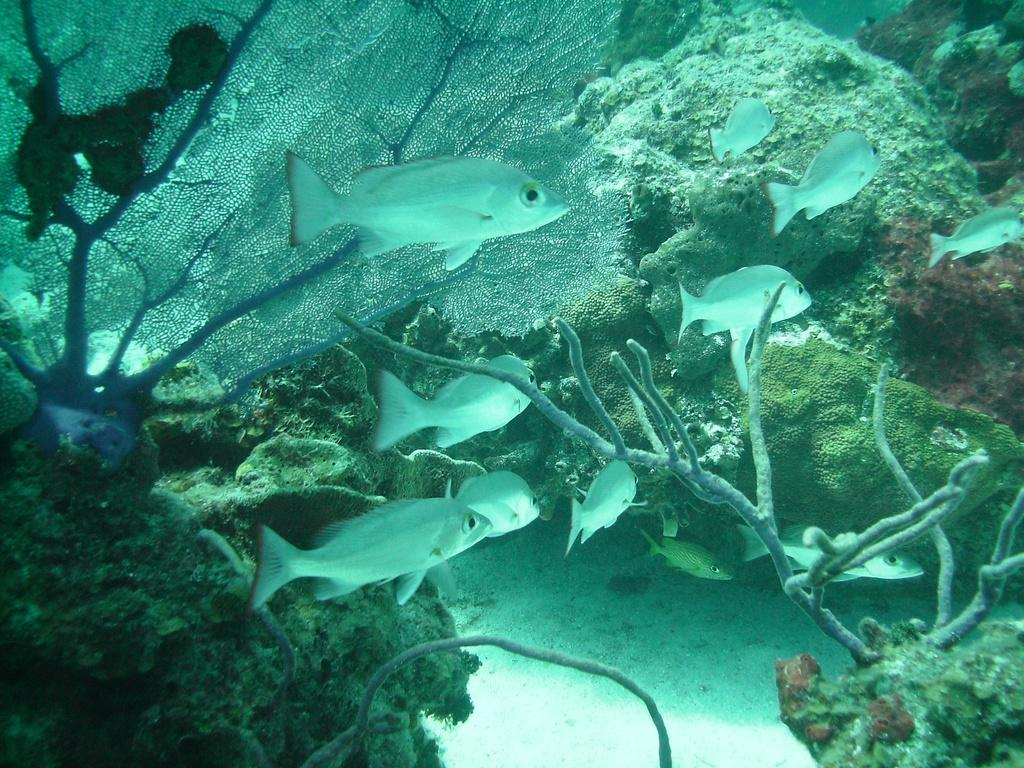What type of animals can be seen in the image? There are fishes in the image. What else is present in the water with the fishes? There is algae in the image. In what environment are the fishes and algae located? The fishes and algae are in water. What type of hydrant can be seen in the image? There is no hydrant present in the image; it features fishes and algae in water. Can you recite the list of items mentioned in the image? There is no list mentioned in the image; it only contains fishes and algae in water. 